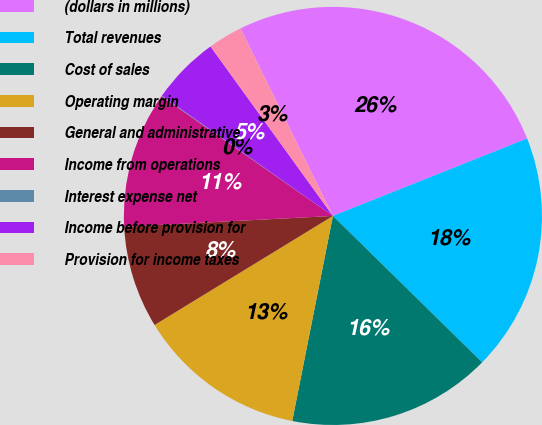Convert chart to OTSL. <chart><loc_0><loc_0><loc_500><loc_500><pie_chart><fcel>(dollars in millions)<fcel>Total revenues<fcel>Cost of sales<fcel>Operating margin<fcel>General and administrative<fcel>Income from operations<fcel>Interest expense net<fcel>Income before provision for<fcel>Provision for income taxes<nl><fcel>26.25%<fcel>18.39%<fcel>15.77%<fcel>13.15%<fcel>7.91%<fcel>10.53%<fcel>0.05%<fcel>5.29%<fcel>2.67%<nl></chart> 